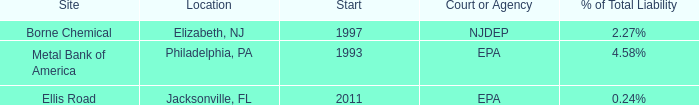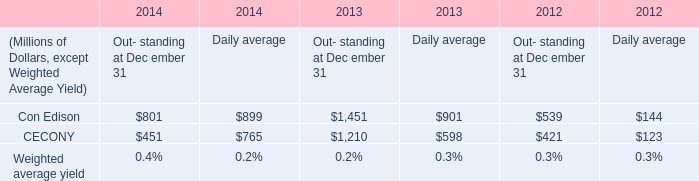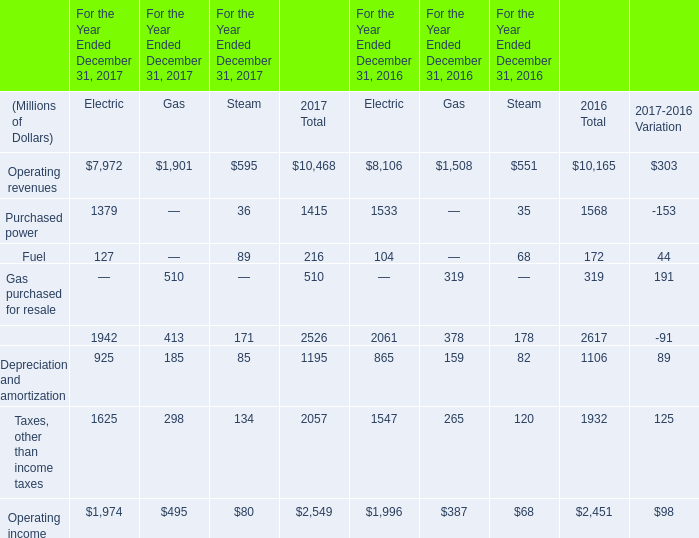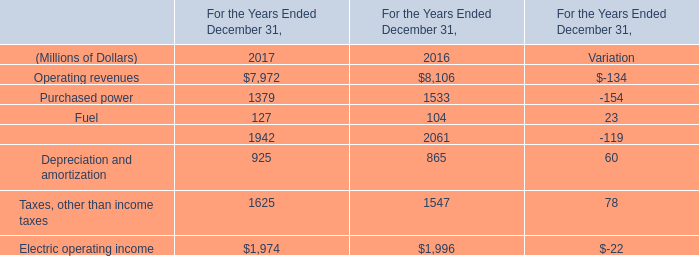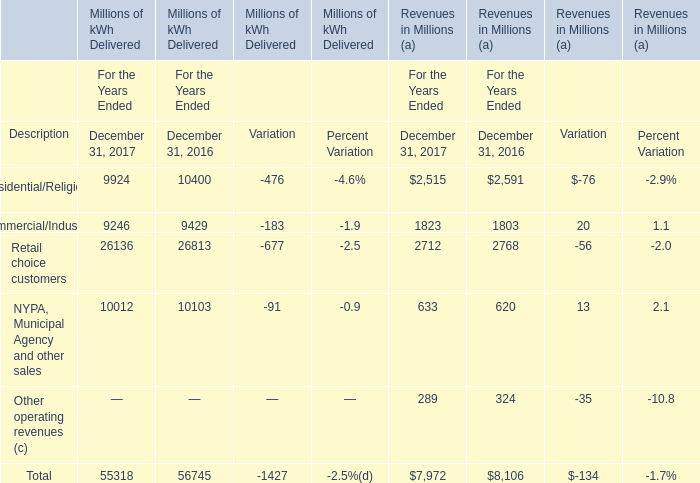What was the total amount of Residential/Religious (b) greater than 9000 in 2017? (in million) 
Answer: 9924. 